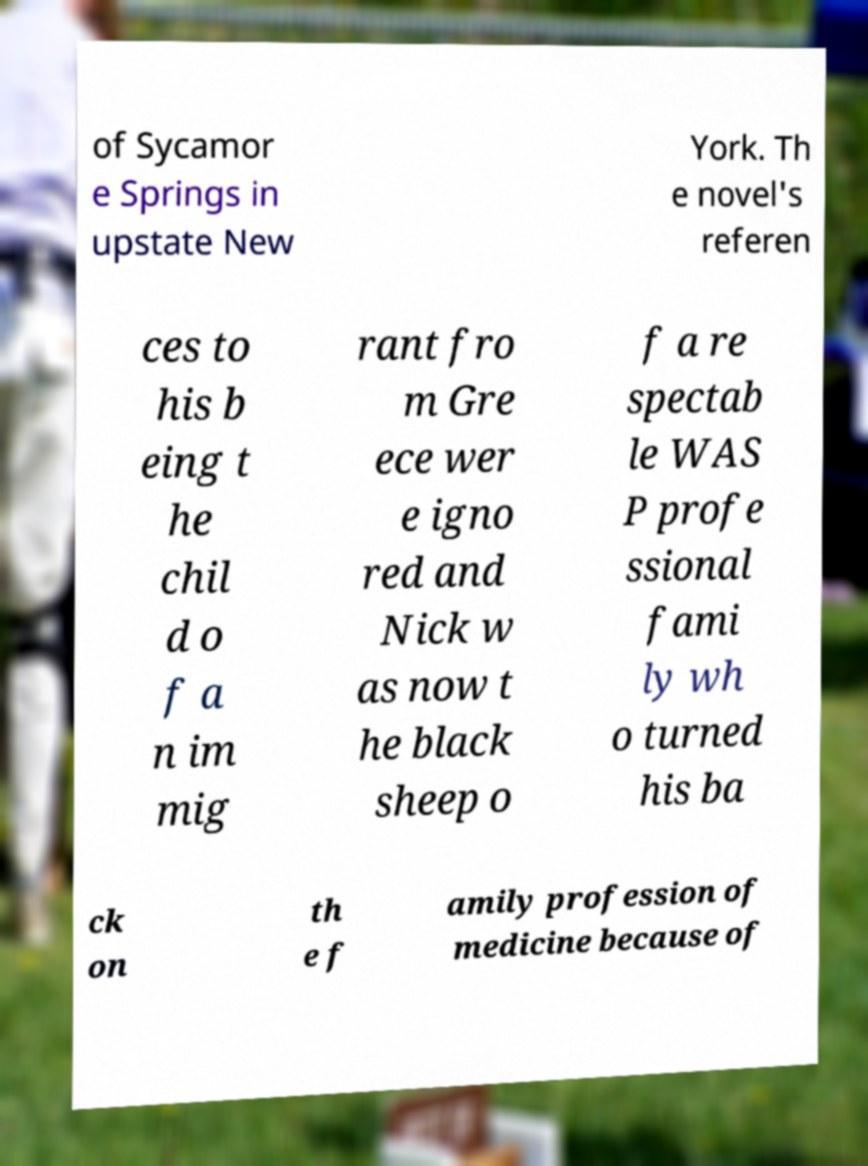Could you extract and type out the text from this image? of Sycamor e Springs in upstate New York. Th e novel's referen ces to his b eing t he chil d o f a n im mig rant fro m Gre ece wer e igno red and Nick w as now t he black sheep o f a re spectab le WAS P profe ssional fami ly wh o turned his ba ck on th e f amily profession of medicine because of 